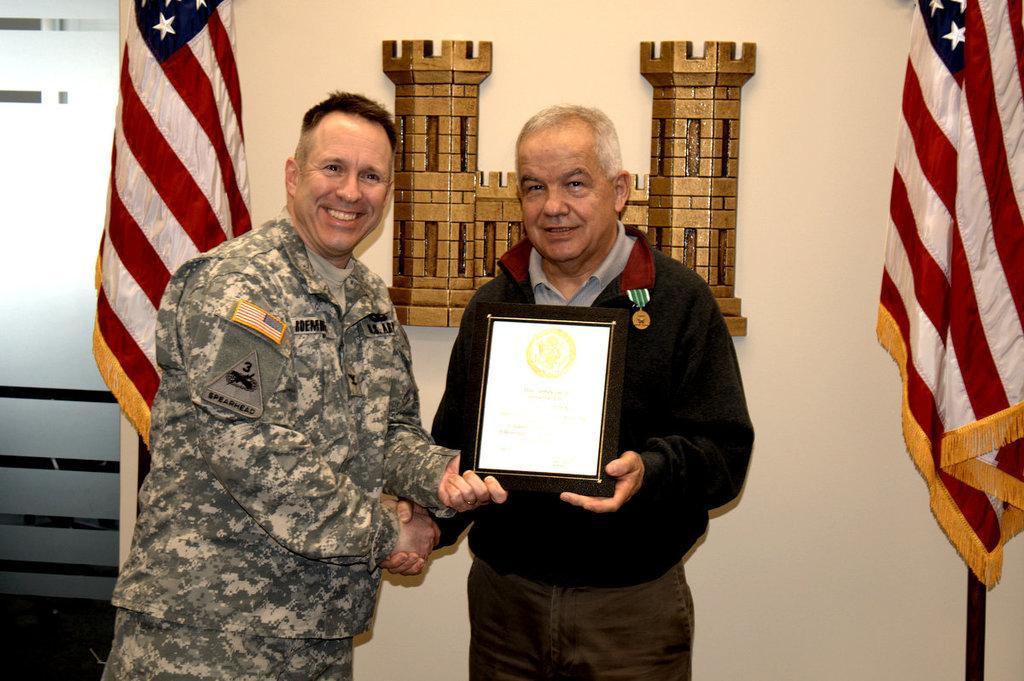Please provide a concise description of this image. In this image we can see two persons are standing, and smiling, there a man is wearing the uniform, and holding the certificate in the hands, beside a man is wearing the sweater, there are flags, at the back there is a wall. 